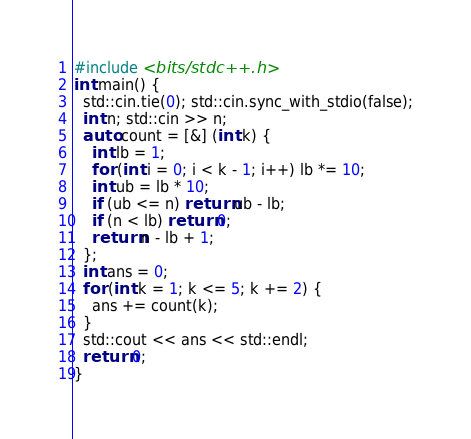Convert code to text. <code><loc_0><loc_0><loc_500><loc_500><_C++_>#include <bits/stdc++.h>
int main() {
  std::cin.tie(0); std::cin.sync_with_stdio(false);
  int n; std::cin >> n;
  auto count = [&] (int k) {
    int lb = 1;
    for (int i = 0; i < k - 1; i++) lb *= 10;
    int ub = lb * 10;
    if (ub <= n) return ub - lb;
    if (n < lb) return 0;
    return n - lb + 1;
  };
  int ans = 0;
  for (int k = 1; k <= 5; k += 2) {
    ans += count(k);
  }
  std::cout << ans << std::endl;
  return 0;
}</code> 